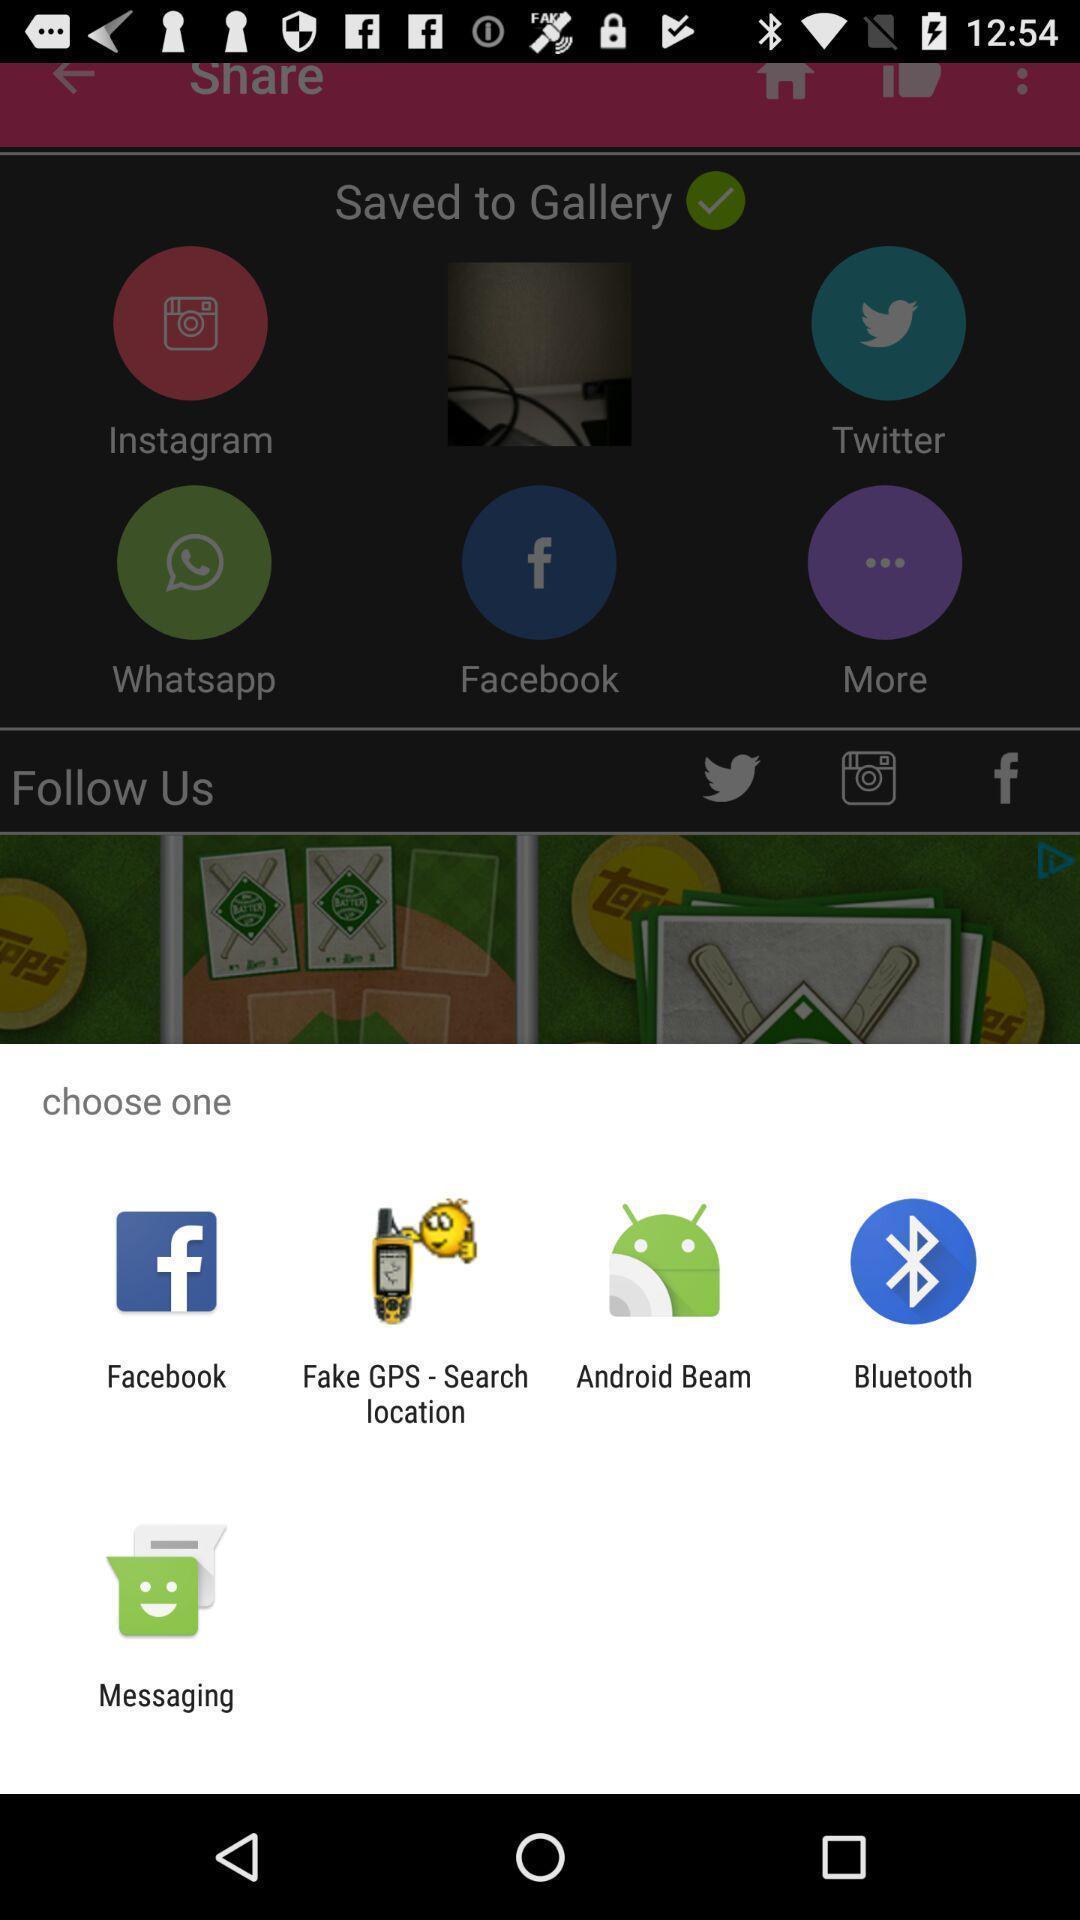Provide a detailed account of this screenshot. Push up message with multiple sharing options. 